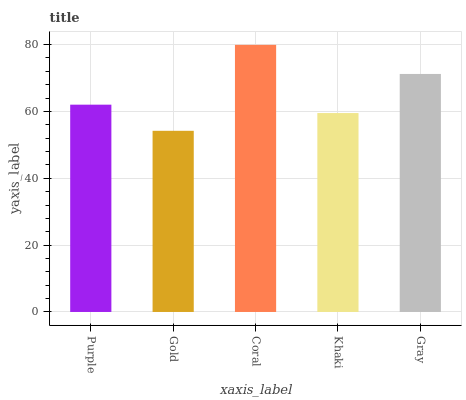Is Gold the minimum?
Answer yes or no. Yes. Is Coral the maximum?
Answer yes or no. Yes. Is Coral the minimum?
Answer yes or no. No. Is Gold the maximum?
Answer yes or no. No. Is Coral greater than Gold?
Answer yes or no. Yes. Is Gold less than Coral?
Answer yes or no. Yes. Is Gold greater than Coral?
Answer yes or no. No. Is Coral less than Gold?
Answer yes or no. No. Is Purple the high median?
Answer yes or no. Yes. Is Purple the low median?
Answer yes or no. Yes. Is Gold the high median?
Answer yes or no. No. Is Khaki the low median?
Answer yes or no. No. 